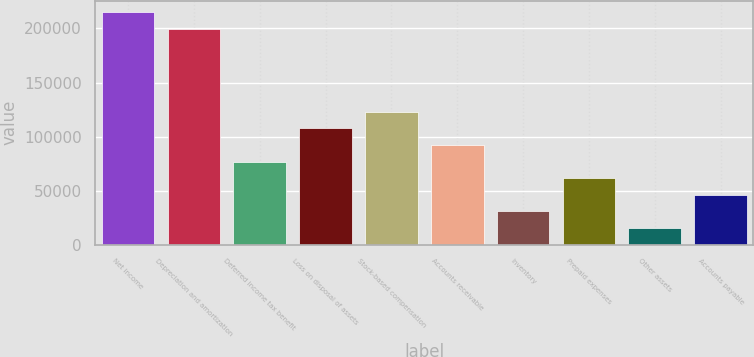Convert chart to OTSL. <chart><loc_0><loc_0><loc_500><loc_500><bar_chart><fcel>Net income<fcel>Depreciation and amortization<fcel>Deferred income tax benefit<fcel>Loss on disposal of assets<fcel>Stock-based compensation<fcel>Accounts receivable<fcel>Inventory<fcel>Prepaid expenses<fcel>Other assets<fcel>Accounts payable<nl><fcel>215074<fcel>199716<fcel>76851.5<fcel>107568<fcel>122926<fcel>92209.6<fcel>30777.2<fcel>61493.4<fcel>15419.1<fcel>46135.3<nl></chart> 